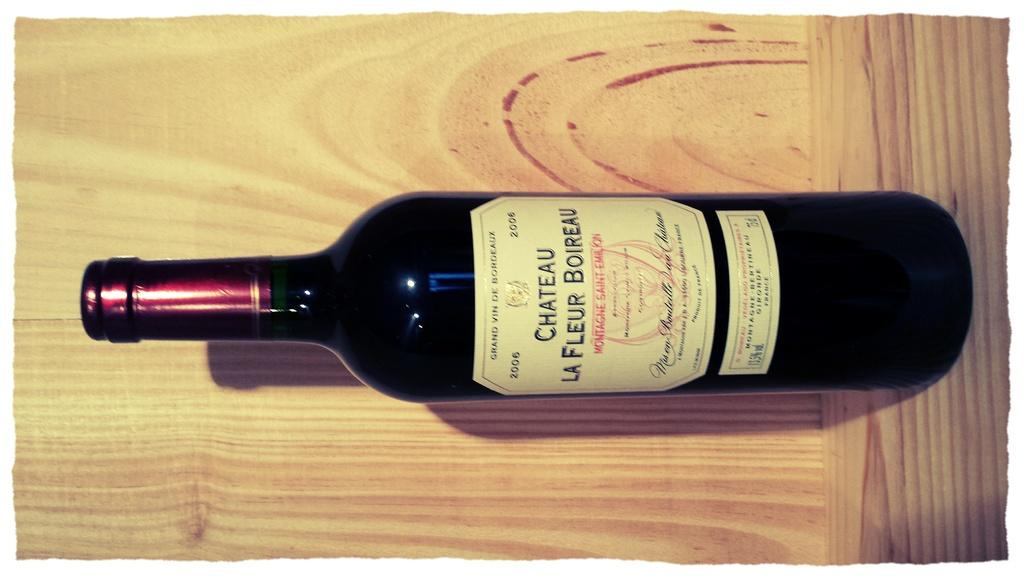<image>
Offer a succinct explanation of the picture presented. A bottle of Chateau La Fleur Boireau wine 